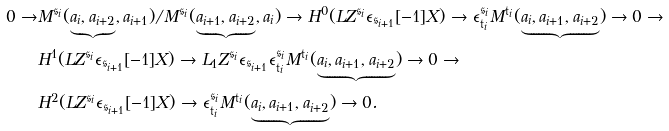<formula> <loc_0><loc_0><loc_500><loc_500>0 \rightarrow & M ^ { \mathfrak { s } _ { i } } ( \underbrace { a _ { i } , a _ { i + 2 } } , a _ { i + 1 } ) / M ^ { \mathfrak { s } _ { i } } ( \underbrace { a _ { i + 1 } , a _ { i + 2 } } , a _ { i } ) \rightarrow H ^ { 0 } ( L Z ^ { \mathfrak { s } _ { i } } \epsilon _ { \mathfrak { s } _ { i + 1 } } [ - 1 ] X ) \rightarrow \epsilon _ { \mathfrak { t } _ { i } } ^ { \mathfrak { s } _ { i } } M ^ { \mathfrak { t } _ { i } } ( \underbrace { a _ { i } , a _ { i + 1 } , a _ { i + 2 } } ) \rightarrow 0 \rightarrow \\ & H ^ { 1 } ( L Z ^ { \mathfrak { s } _ { i } } \epsilon _ { \mathfrak { s } _ { i + 1 } } [ - 1 ] X ) \rightarrow L _ { 1 } Z ^ { \mathfrak { s } _ { i } } \epsilon _ { \mathfrak { s } _ { i + 1 } } \epsilon _ { \mathfrak { t } _ { i } } ^ { \mathfrak { s } _ { i } } M ^ { \mathfrak { t } _ { i } } ( \underbrace { a _ { i } , a _ { i + 1 } , a _ { i + 2 } } ) \rightarrow 0 \rightarrow \\ & H ^ { 2 } ( L Z ^ { \mathfrak { s } _ { i } } \epsilon _ { \mathfrak { s } _ { i + 1 } } [ - 1 ] X ) \rightarrow \epsilon _ { \mathfrak { t } _ { i } } ^ { \mathfrak { s } _ { i } } M ^ { \mathfrak { t } _ { i } } ( \underbrace { a _ { i } , a _ { i + 1 } , a _ { i + 2 } } ) \rightarrow 0 .</formula> 